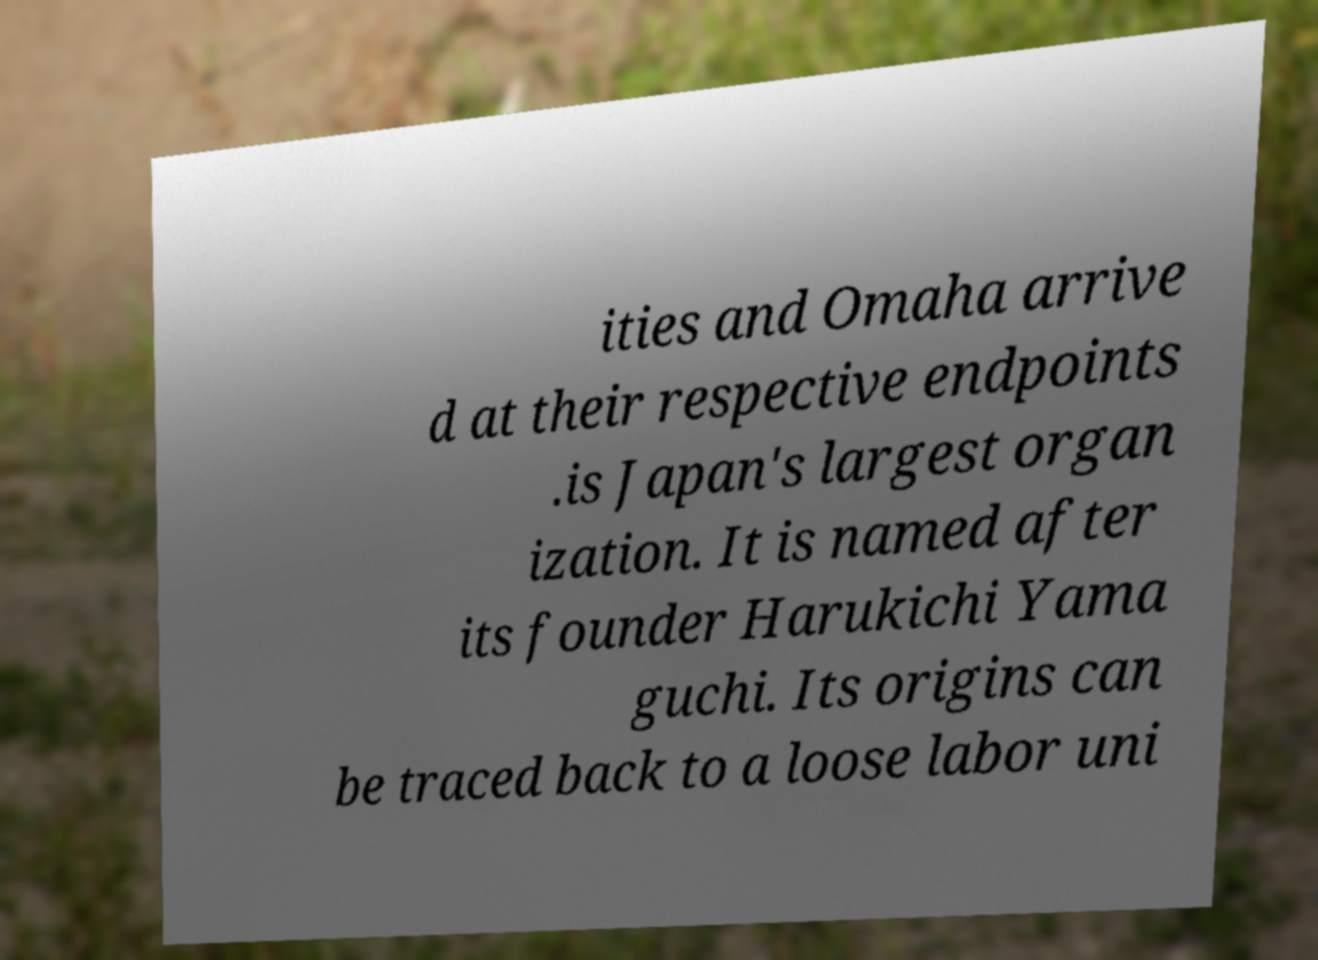Can you read and provide the text displayed in the image?This photo seems to have some interesting text. Can you extract and type it out for me? ities and Omaha arrive d at their respective endpoints .is Japan's largest organ ization. It is named after its founder Harukichi Yama guchi. Its origins can be traced back to a loose labor uni 